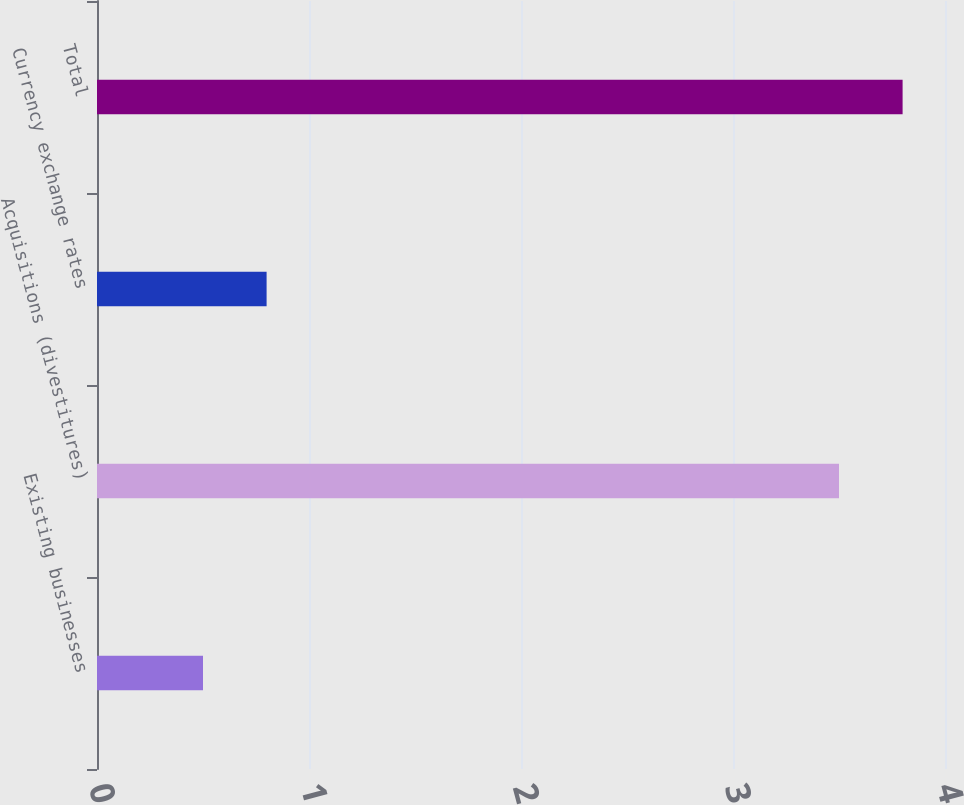<chart> <loc_0><loc_0><loc_500><loc_500><bar_chart><fcel>Existing businesses<fcel>Acquisitions (divestitures)<fcel>Currency exchange rates<fcel>Total<nl><fcel>0.5<fcel>3.5<fcel>0.8<fcel>3.8<nl></chart> 